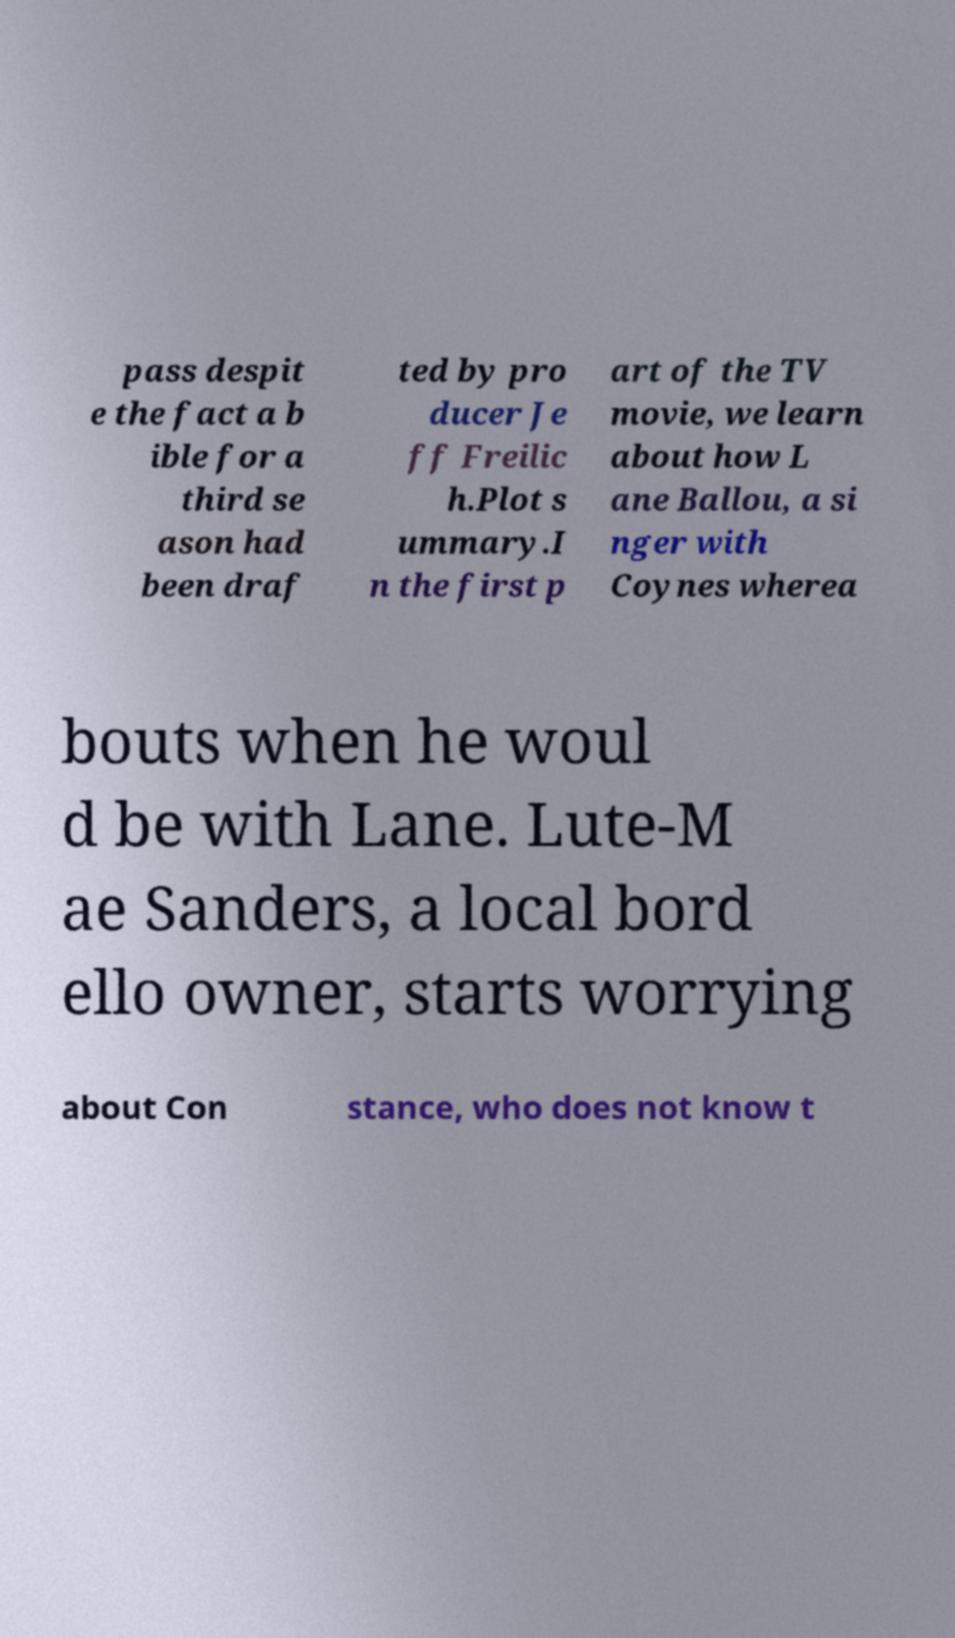What messages or text are displayed in this image? I need them in a readable, typed format. pass despit e the fact a b ible for a third se ason had been draf ted by pro ducer Je ff Freilic h.Plot s ummary.I n the first p art of the TV movie, we learn about how L ane Ballou, a si nger with Coynes wherea bouts when he woul d be with Lane. Lute-M ae Sanders, a local bord ello owner, starts worrying about Con stance, who does not know t 